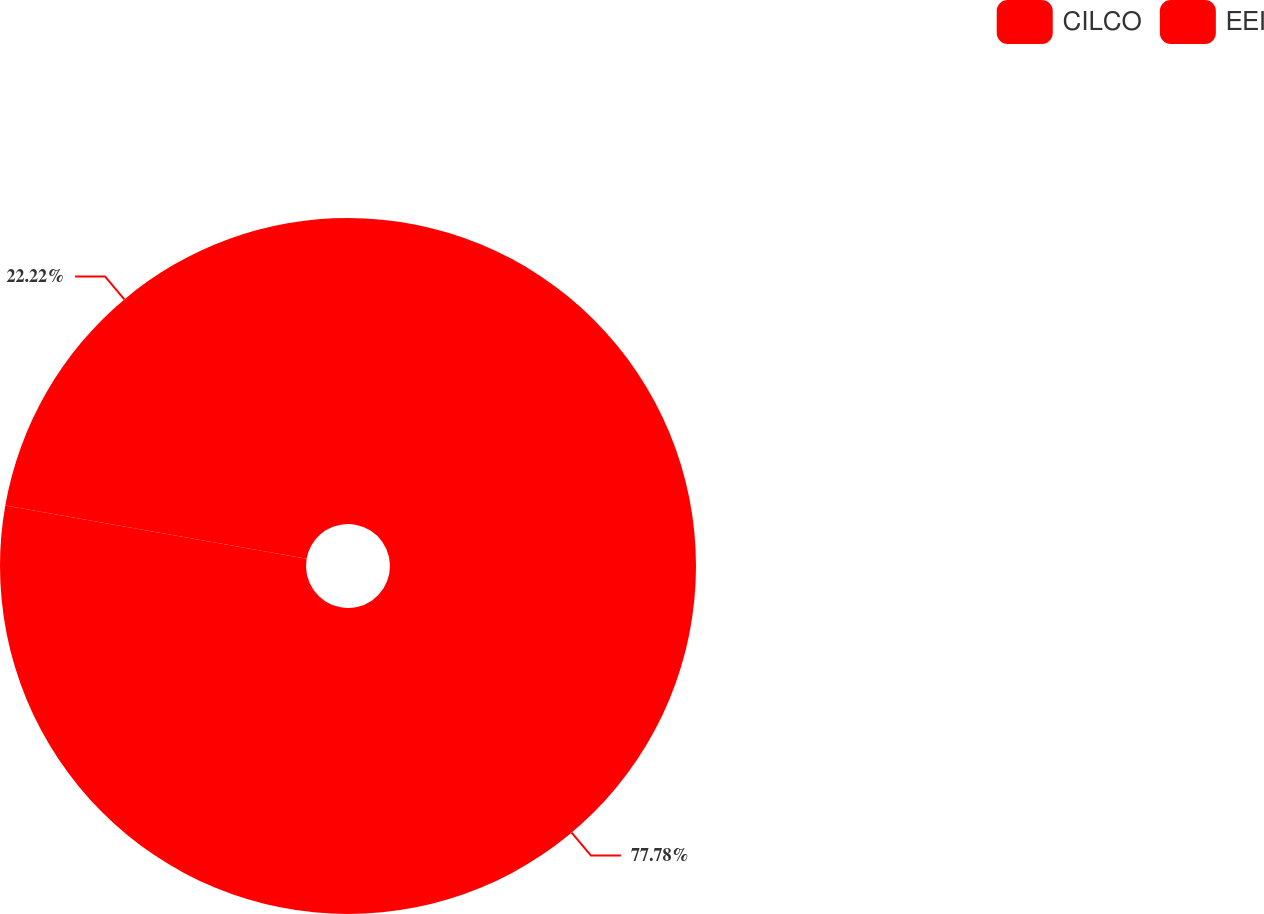<chart> <loc_0><loc_0><loc_500><loc_500><pie_chart><fcel>CILCO<fcel>EEI<nl><fcel>77.78%<fcel>22.22%<nl></chart> 